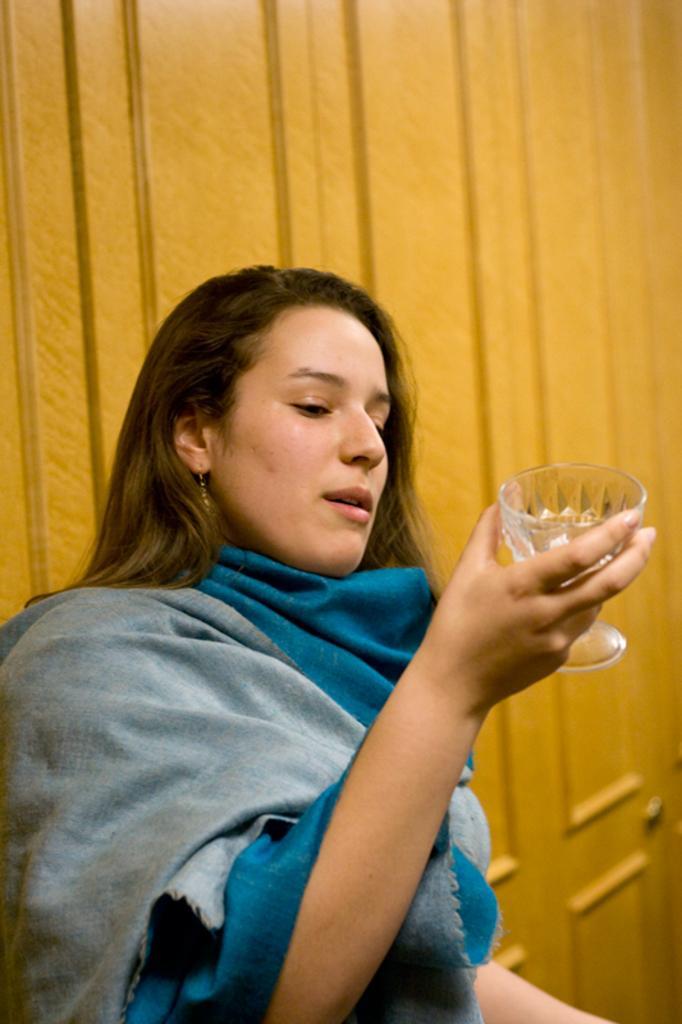In one or two sentences, can you explain what this image depicts? In this picture we can see a woman wearing a shall and holding a glass in her hand. We can see a wooden object in the background. 